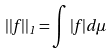Convert formula to latex. <formula><loc_0><loc_0><loc_500><loc_500>| | f | | _ { 1 } = \int | f | d \mu</formula> 